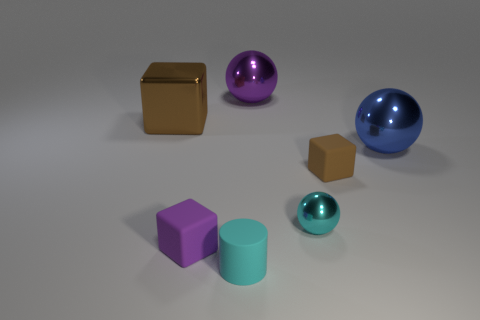Subtract all tiny cubes. How many cubes are left? 1 Subtract all gray spheres. How many brown cubes are left? 2 Add 2 large objects. How many objects exist? 9 Subtract all cubes. How many objects are left? 4 Add 7 brown matte blocks. How many brown matte blocks exist? 8 Subtract 0 green blocks. How many objects are left? 7 Subtract all tiny purple rubber blocks. Subtract all tiny cyan objects. How many objects are left? 4 Add 3 cyan matte things. How many cyan matte things are left? 4 